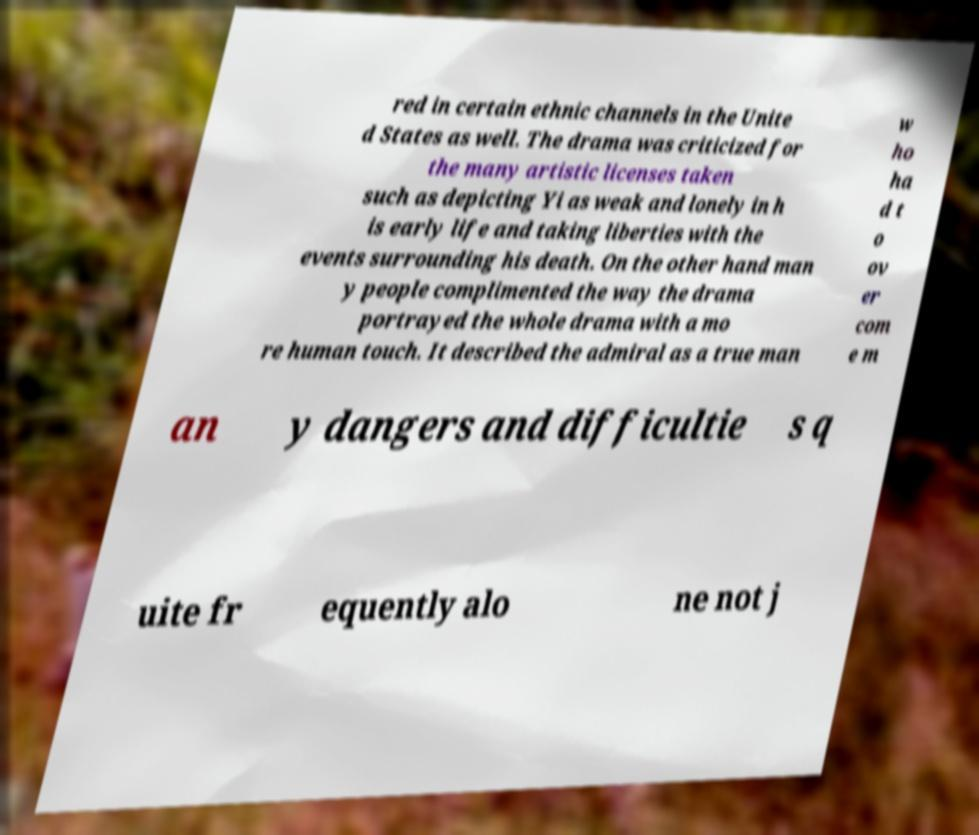What messages or text are displayed in this image? I need them in a readable, typed format. red in certain ethnic channels in the Unite d States as well. The drama was criticized for the many artistic licenses taken such as depicting Yi as weak and lonely in h is early life and taking liberties with the events surrounding his death. On the other hand man y people complimented the way the drama portrayed the whole drama with a mo re human touch. It described the admiral as a true man w ho ha d t o ov er com e m an y dangers and difficultie s q uite fr equently alo ne not j 